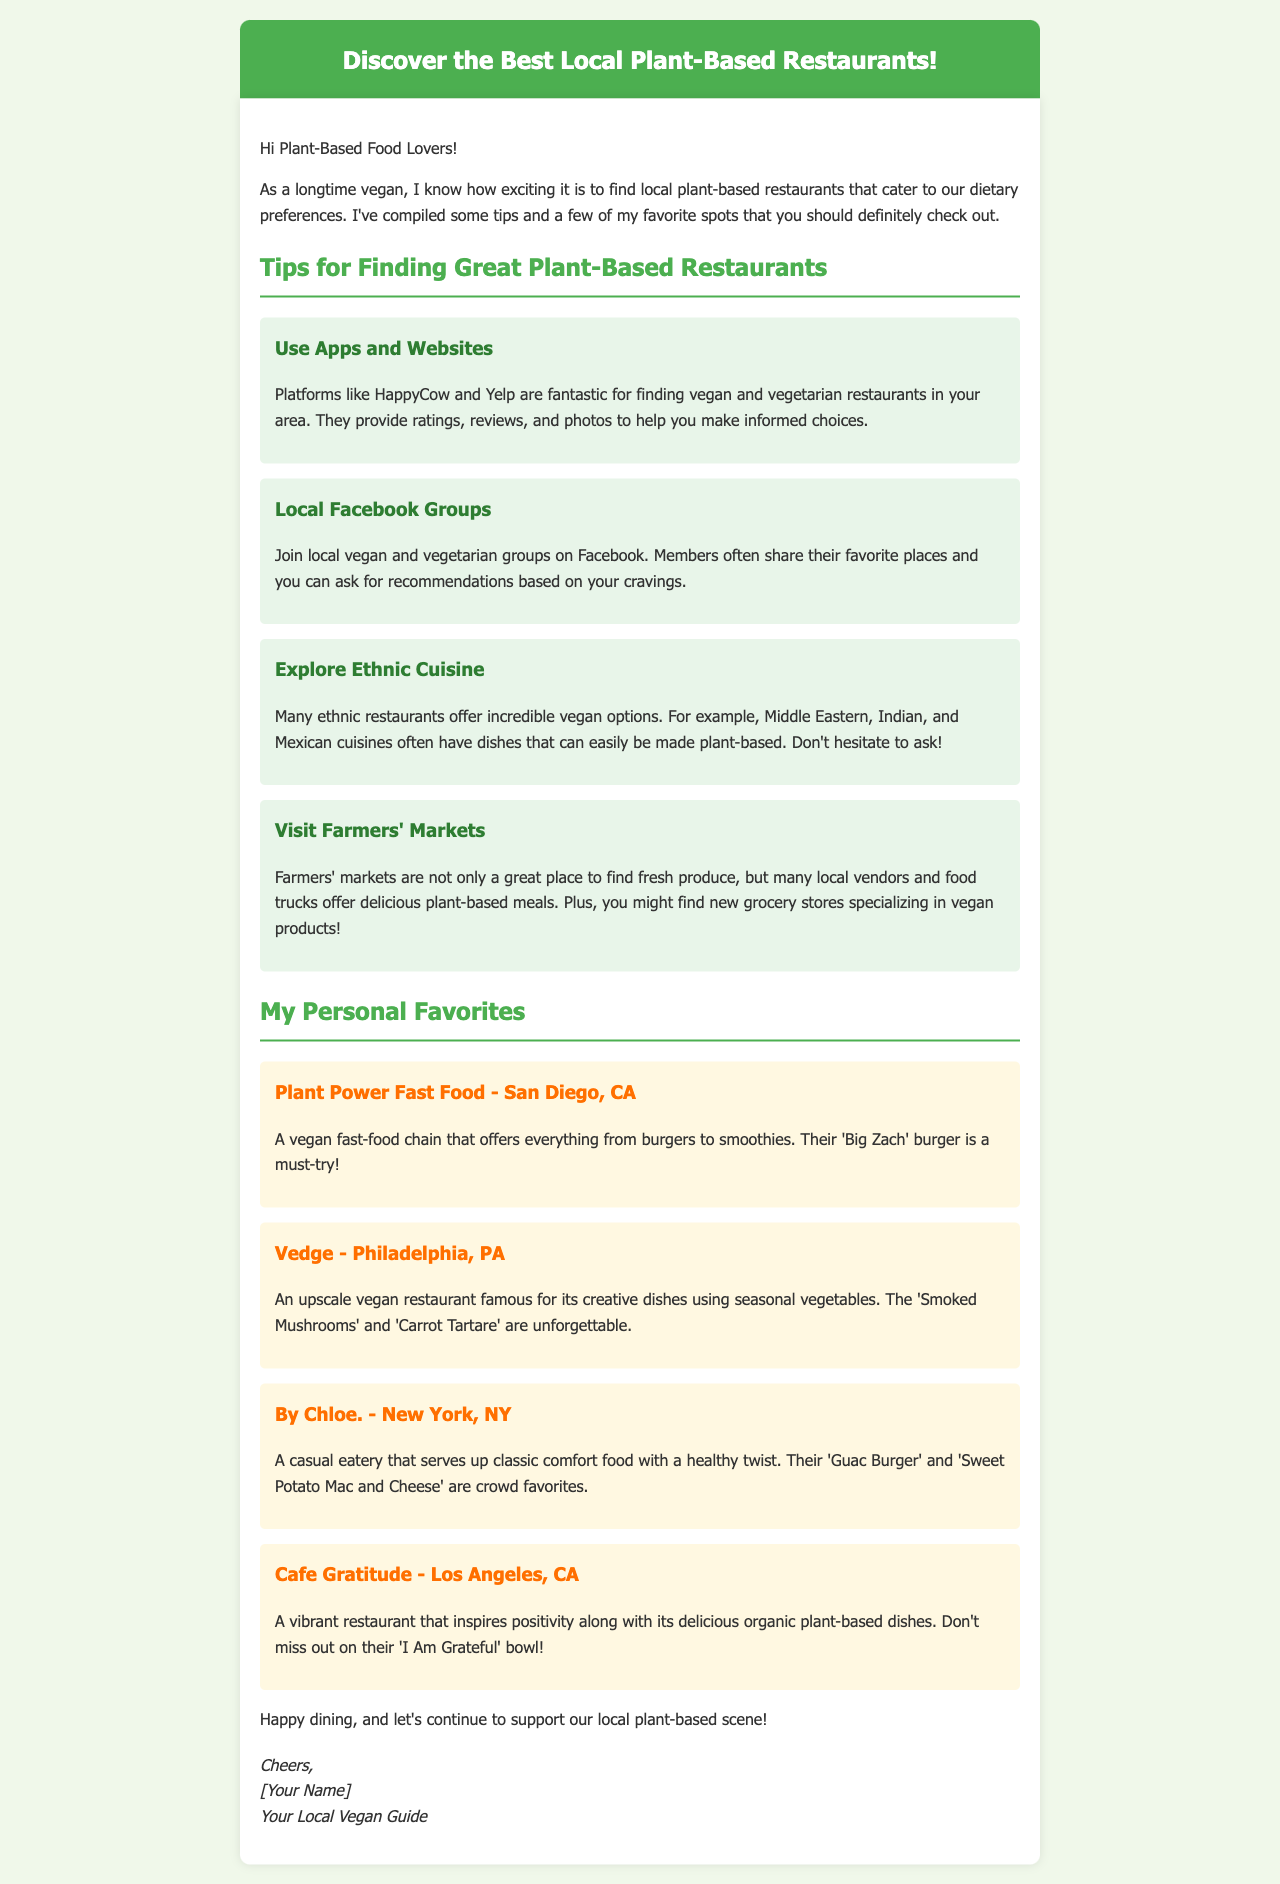What is the title of the email? The title of the email is displayed prominently at the top of the document, which is "Discover the Best Local Plant-Based Restaurants!"
Answer: Discover the Best Local Plant-Based Restaurants! Which restaurant offers a 'Big Zach' burger? The restaurant that offers a 'Big Zach' burger is specifically mentioned in the personal favorites section.
Answer: Plant Power Fast Food What is one platform recommended for finding plant-based restaurants? The email suggests that platforms like HappyCow and Yelp are great resources for finding vegan and vegetarian restaurants.
Answer: HappyCow How many personal favorite restaurants are listed in the email? The email lists a total of four personal favorite restaurants under the designated section.
Answer: Four What dish is mentioned as a must-try at Cafe Gratitude? The email highlights a specific dish that is a must-try at Cafe Gratitude.
Answer: I Am Grateful bowl What type of cuisine is suggested for finding vegan options besides vegan-specific restaurants? The email points out that many ethnic restaurants offer incredible vegan options, mentioning a few types of cuisine.
Answer: Ethnic cuisine What color is the background of the email content? The document describes the background color of the content area, which is white.
Answer: White What is the purpose of joining local Facebook groups according to the email? The email explains that joining local vegan and vegetarian groups on Facebook helps members share their favorite places and ask for recommendations.
Answer: Recommendations Which city is Vedge located in? The location of Vedge is specifically noted in the favorite restaurant section of the email.
Answer: Philadelphia, PA 